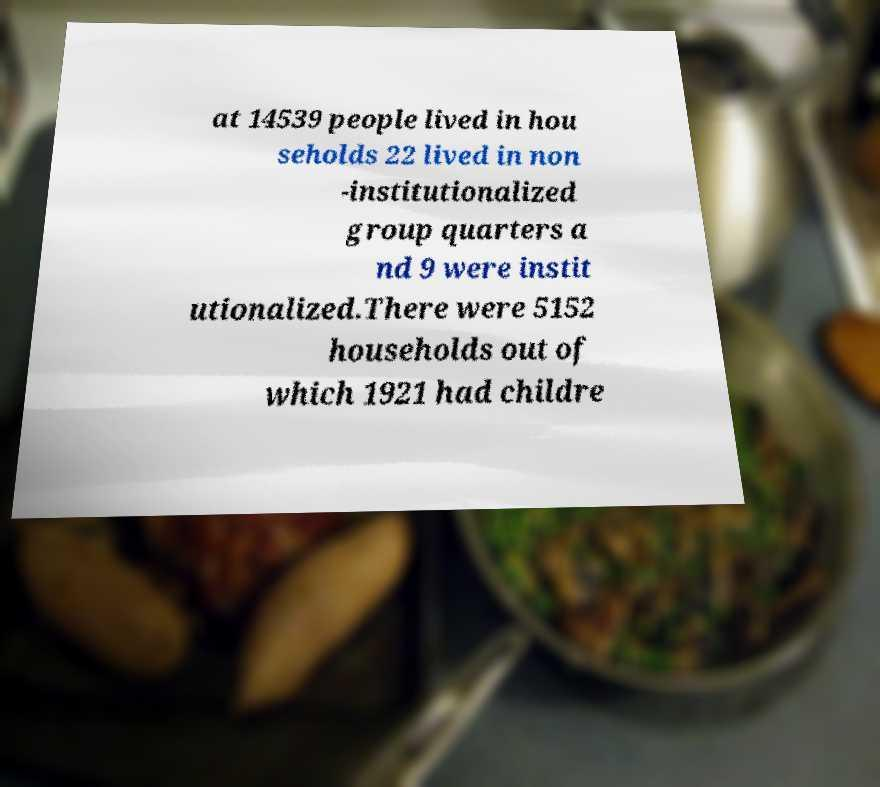Can you accurately transcribe the text from the provided image for me? at 14539 people lived in hou seholds 22 lived in non -institutionalized group quarters a nd 9 were instit utionalized.There were 5152 households out of which 1921 had childre 